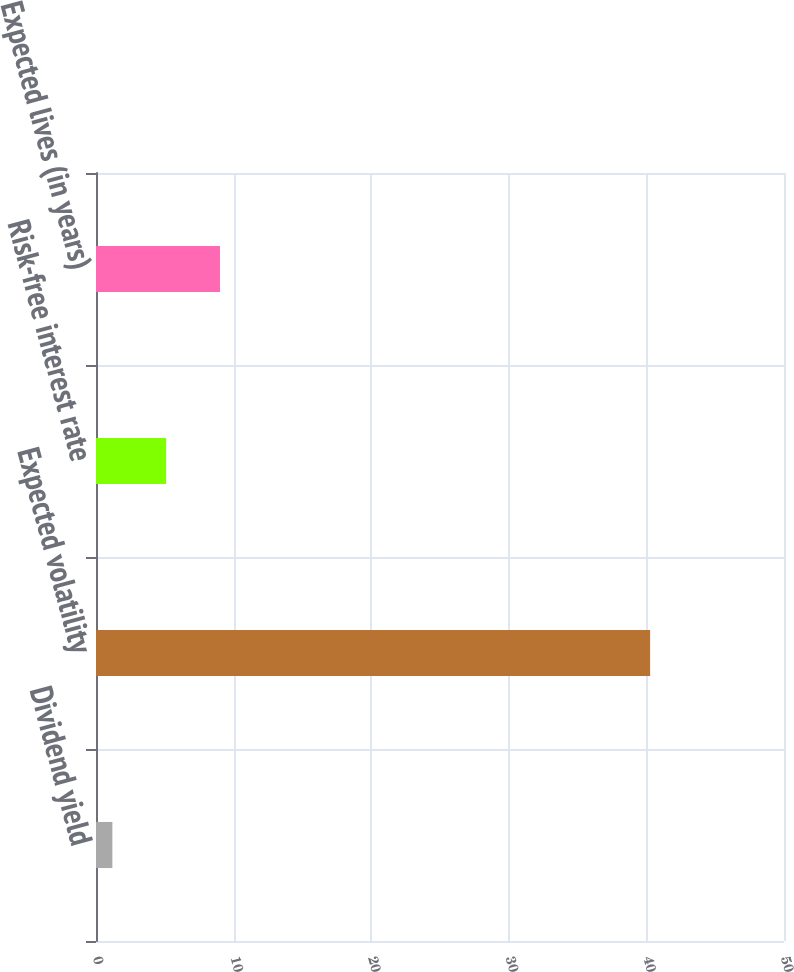<chart> <loc_0><loc_0><loc_500><loc_500><bar_chart><fcel>Dividend yield<fcel>Expected volatility<fcel>Risk-free interest rate<fcel>Expected lives (in years)<nl><fcel>1.19<fcel>40.27<fcel>5.1<fcel>9.01<nl></chart> 